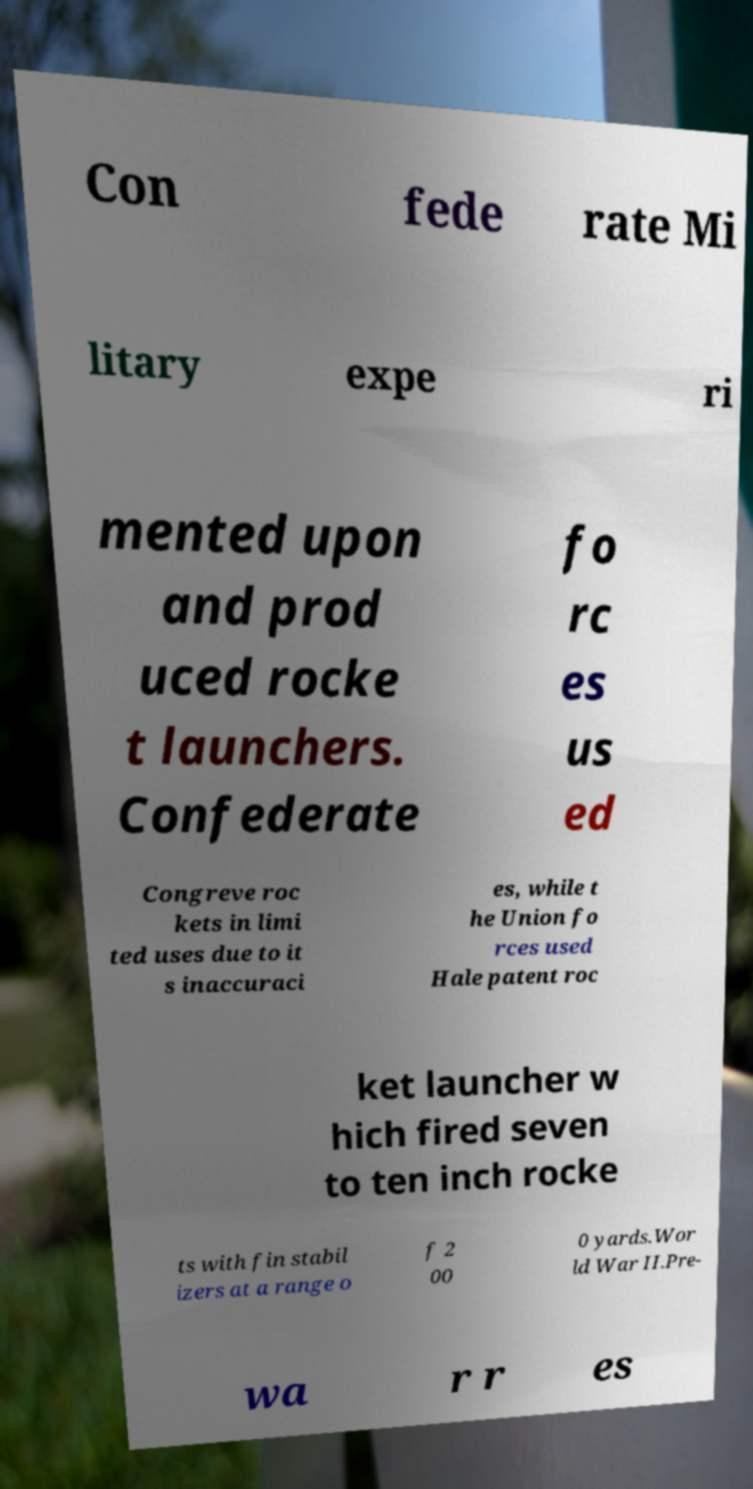What messages or text are displayed in this image? I need them in a readable, typed format. Con fede rate Mi litary expe ri mented upon and prod uced rocke t launchers. Confederate fo rc es us ed Congreve roc kets in limi ted uses due to it s inaccuraci es, while t he Union fo rces used Hale patent roc ket launcher w hich fired seven to ten inch rocke ts with fin stabil izers at a range o f 2 00 0 yards.Wor ld War II.Pre- wa r r es 